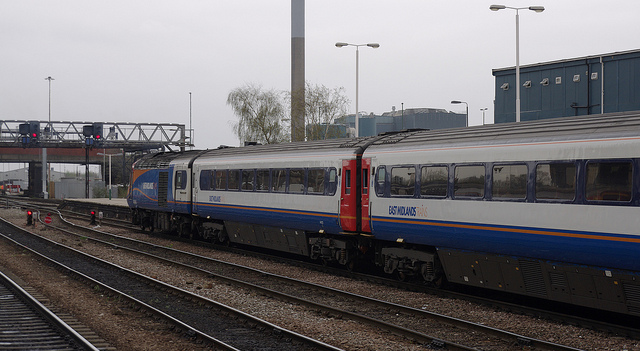<image>Where is platform number 1? There is no platform number 1 shown in the image. It could possibly be on the left, right or behind the train. Where is platform number 1? I don't know where platform number 1 is. There are no platforms shown in the image. 